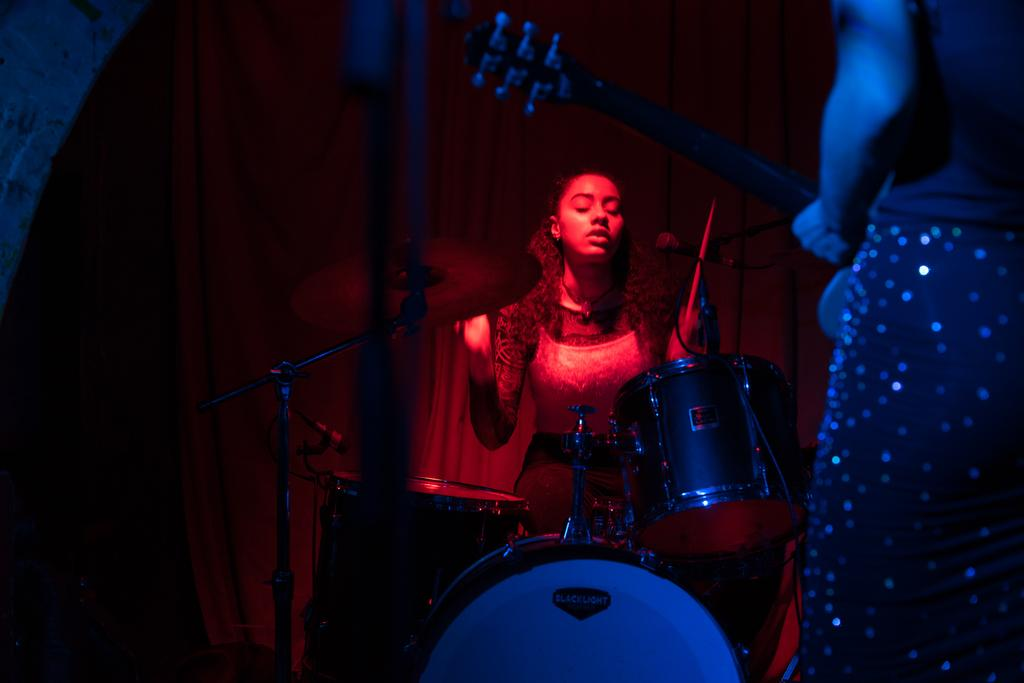What is the person at the right front of the image doing? The person is standing and holding a guitar. What instrument is being played by another person in the image? There is a person playing drums in the background of the image. How does the person change the channel on the guitar in the image? There is no channel to change on the guitar, as it is a musical instrument and not an electronic device. 